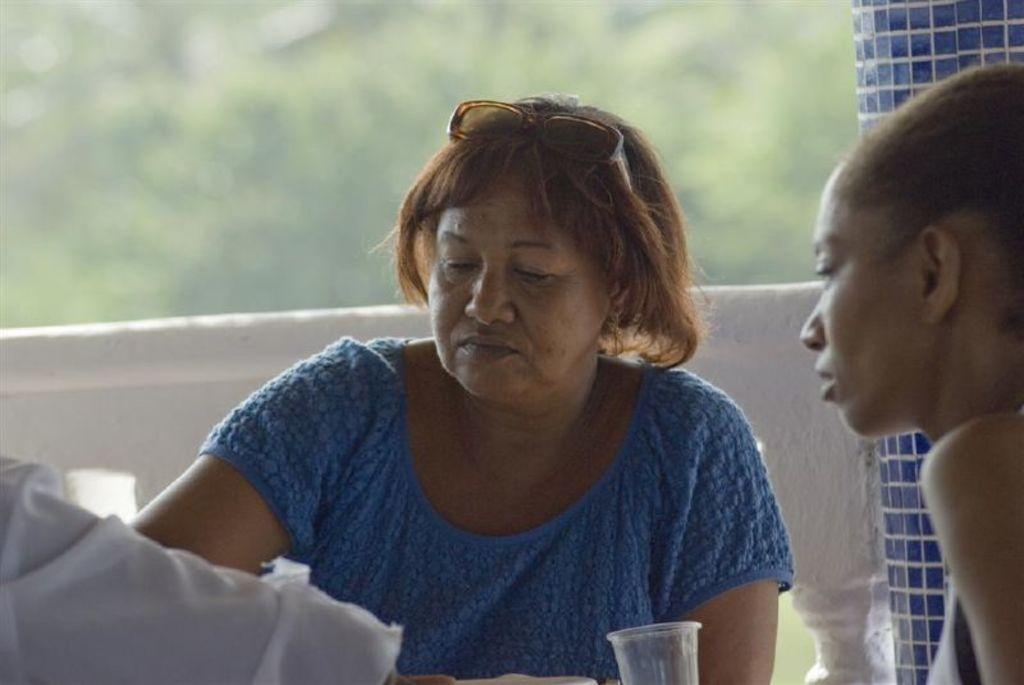How many people are sitting in the center of the image? There are two persons sitting in the center of the image. What is placed in front of the two persons? There is a glass in front of the two persons. What can be seen in the background of the image? There is a pole and a fence in the background of the image. What type of doctor is standing near the fence in the image? There is no doctor present in the image; it only features two persons sitting and a glass in front of them, along with a pole and a fence in the background. 